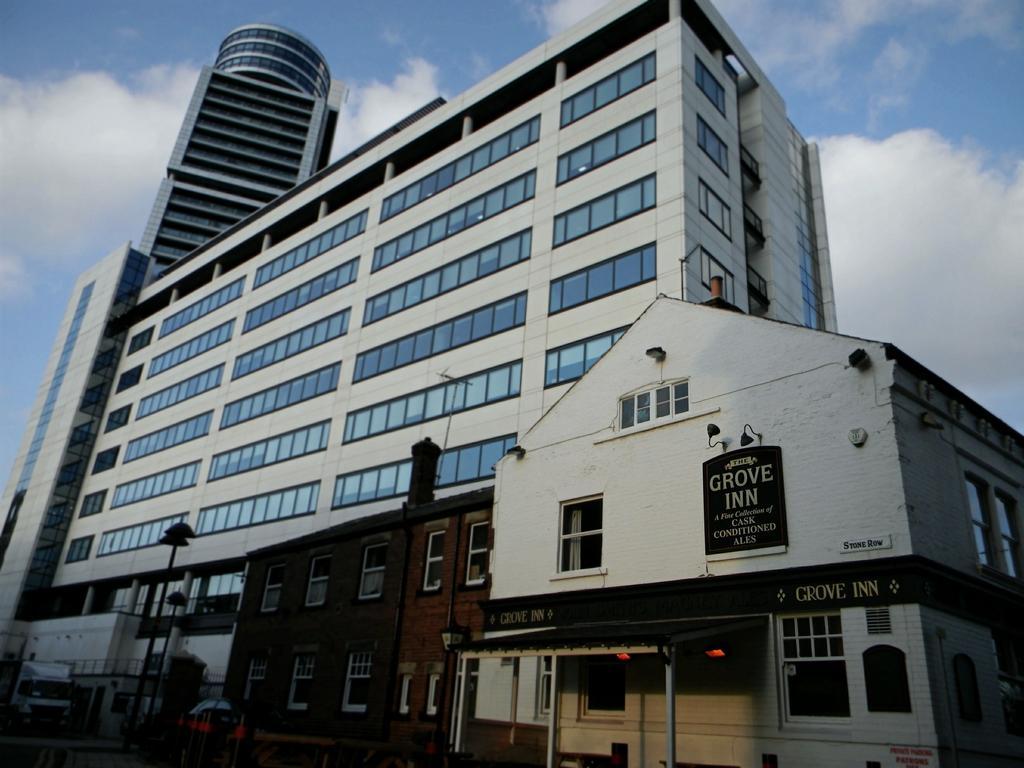Can you describe this image briefly? In this picture we can see buildings with windows, poles, vehicles and in the background we can see the sky with clouds. 